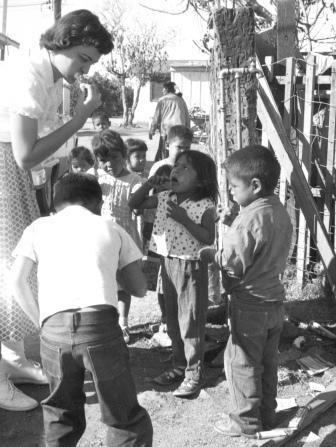How many adults are shown?
Give a very brief answer. 2. How many people can be seen?
Give a very brief answer. 4. 